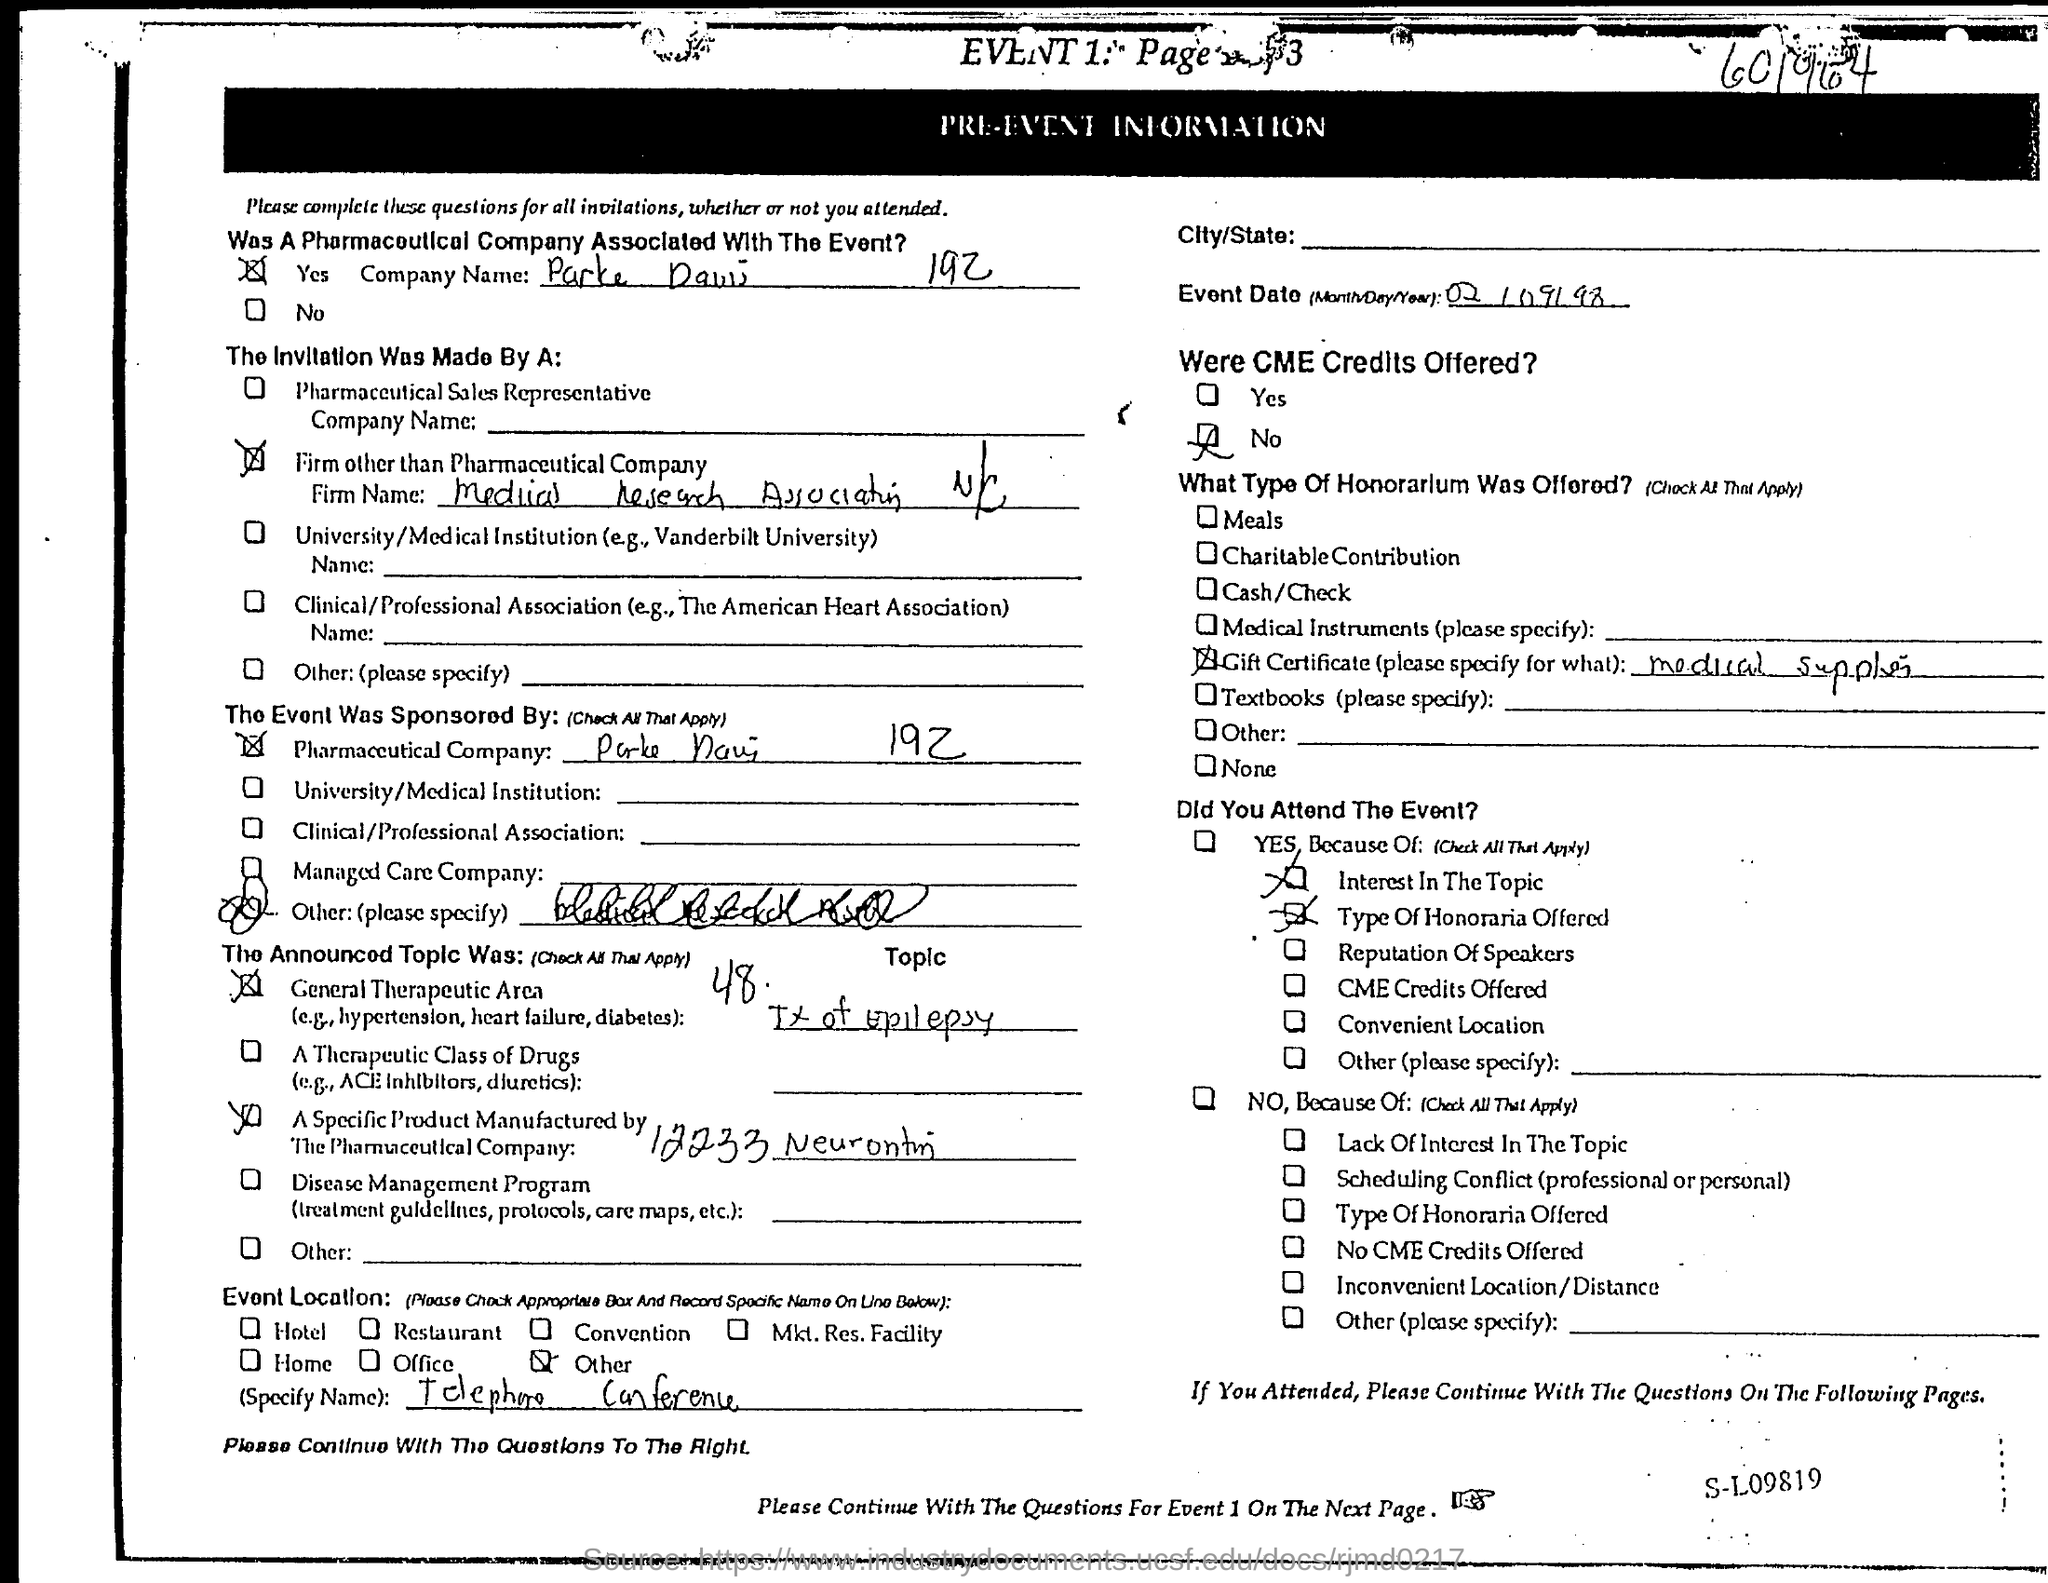Mention a couple of crucial points in this snapshot. The invitation was extended by a firm that was not affiliated with the pharmaceutical industry. The event date is February 9, 1998. 